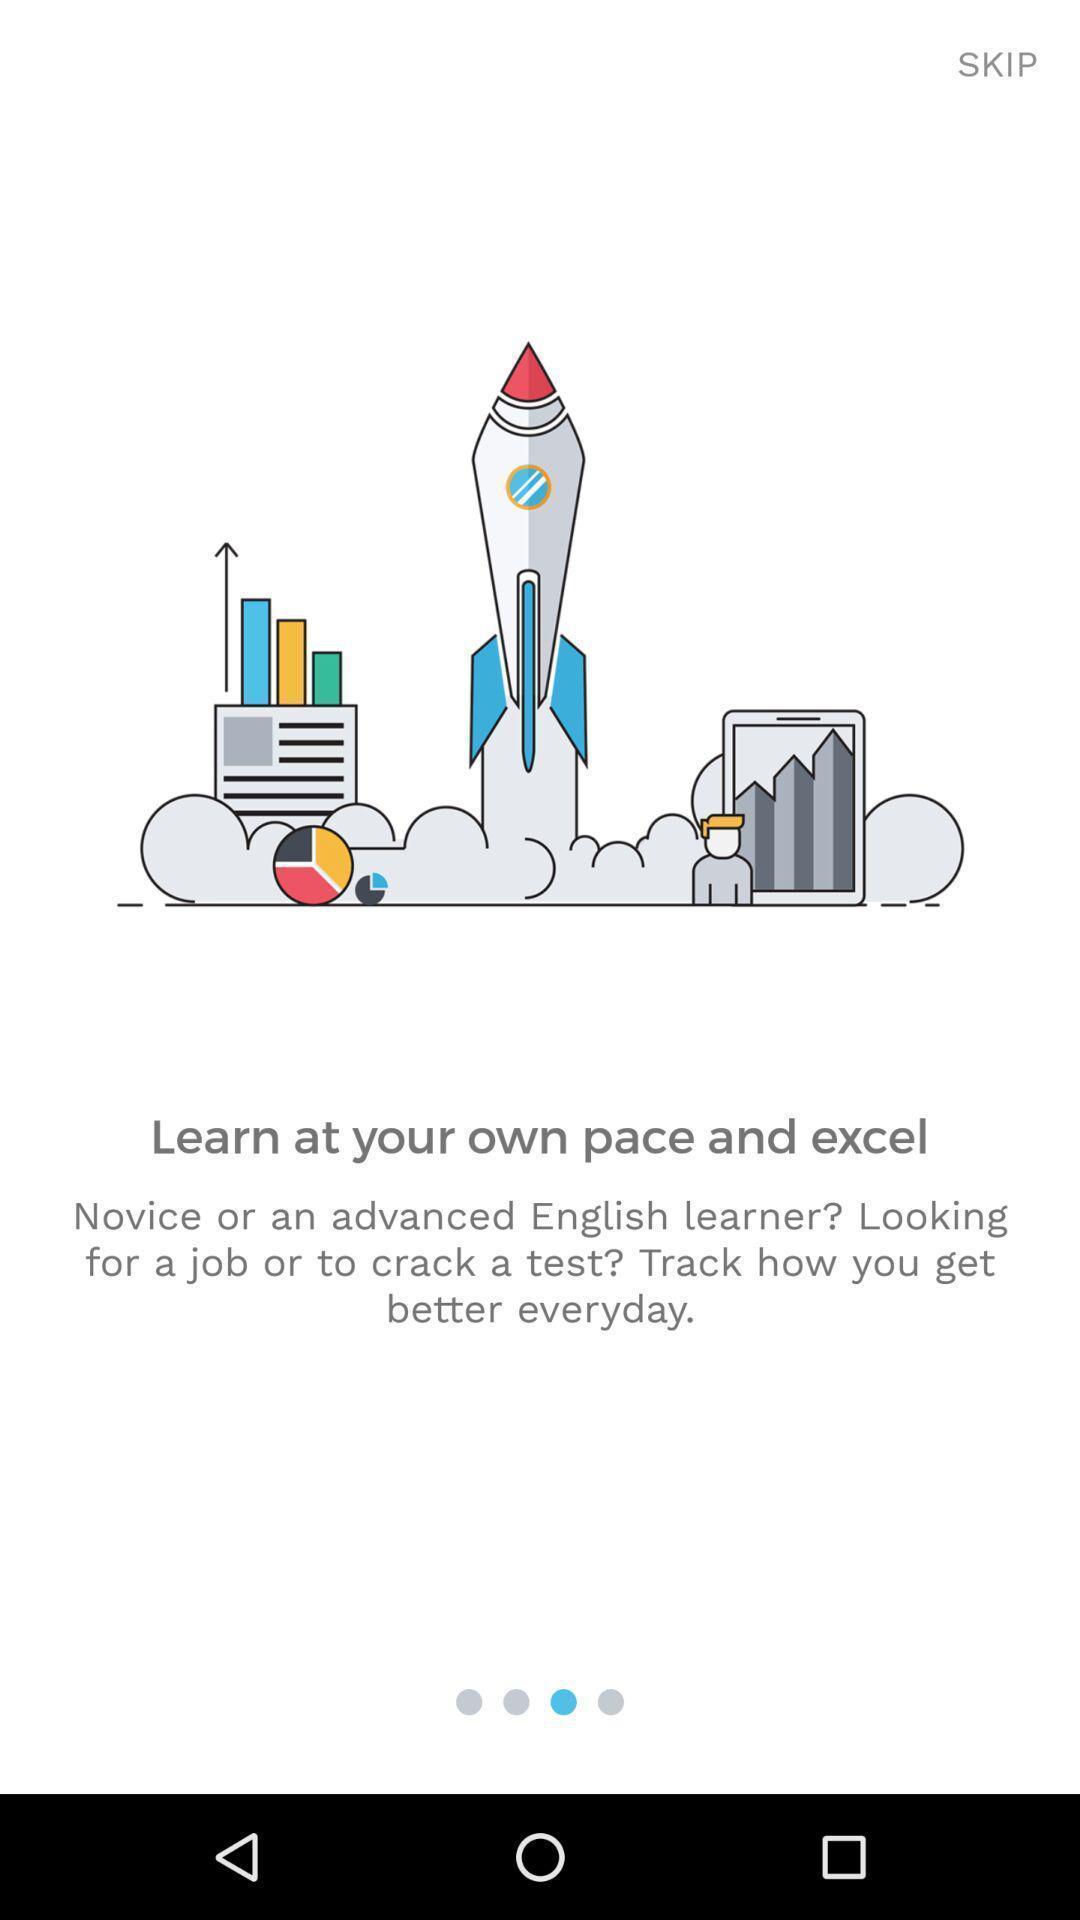Provide a description of this screenshot. Welcome page. 